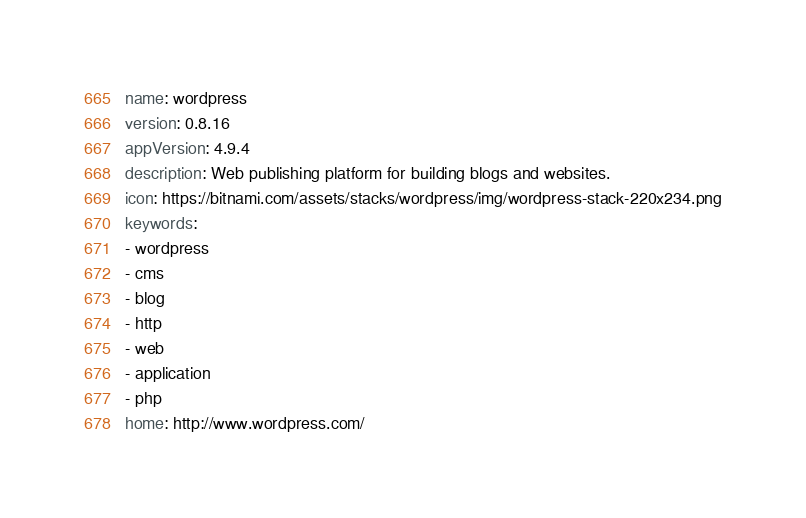<code> <loc_0><loc_0><loc_500><loc_500><_YAML_>name: wordpress
version: 0.8.16
appVersion: 4.9.4
description: Web publishing platform for building blogs and websites.
icon: https://bitnami.com/assets/stacks/wordpress/img/wordpress-stack-220x234.png
keywords:
- wordpress
- cms
- blog
- http
- web
- application
- php
home: http://www.wordpress.com/</code> 